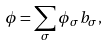Convert formula to latex. <formula><loc_0><loc_0><loc_500><loc_500>\phi = \sum _ { \sigma } \phi _ { \sigma } b _ { \sigma } ,</formula> 